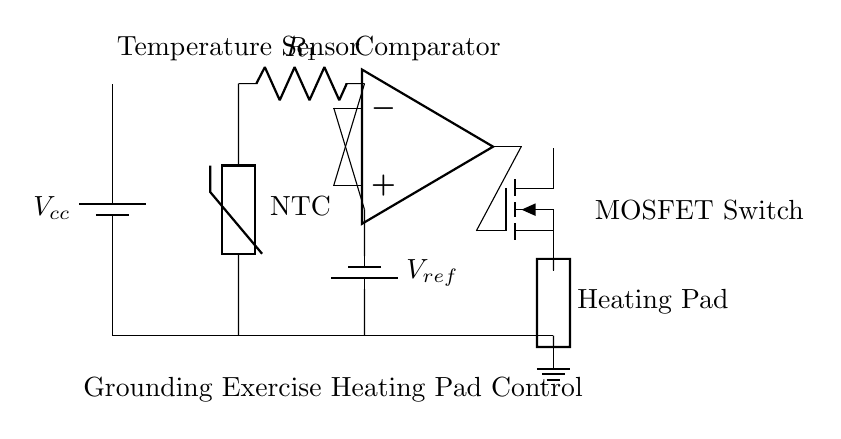What is the type of temperature sensor used in this circuit? The circuit uses an NTC thermistor as the temperature sensor, which is indicated by the label next to the component. NTC stands for Negative Temperature Coefficient, meaning its resistance decreases as the temperature increases.
Answer: NTC thermistor What does the comparator do in this circuit? The comparator, shown as the op-amp symbol, compares the voltage from the temperature sensor with a reference voltage to determine whether to turn on the MOSFET switch. If the temperature exceeds a certain threshold, the comparator output changes, regulating the heating pad accordingly.
Answer: Regulates heating What is the role of the MOSFET in this circuit? The MOSFET acts as a switch that controls the current flowing to the heating pad based on the output from the comparator (op-amp). If the comparator indicates that heating is necessary, it allows current to flow to the heating pad.
Answer: Current switch What is the reference voltage labeled in the circuit? The reference voltage is labeled as V ref, and it is used by the comparator to set the temperature threshold for the operation of the heating pad. The value of this voltage influences at what temperature the MOSFET will turn on or off.
Answer: V ref How many main components are visible in the circuit? The main components visible in the circuit diagram include a battery (power supply), NTC thermistor (temperature sensor), resistor, op-amp (comparator), MOSFET switch, and the heating pad itself. Counting these yields six main components.
Answer: Six components In what configuration is the thermistor connected in the circuit? The thermistor is connected as part of a voltage divider with a resistor, where it forms a connection to the op-amp input for voltage comparison. This configuration allows the voltage across the thermistor to change with temperature, providing the comparator with a relevant signal.
Answer: Voltage divider 